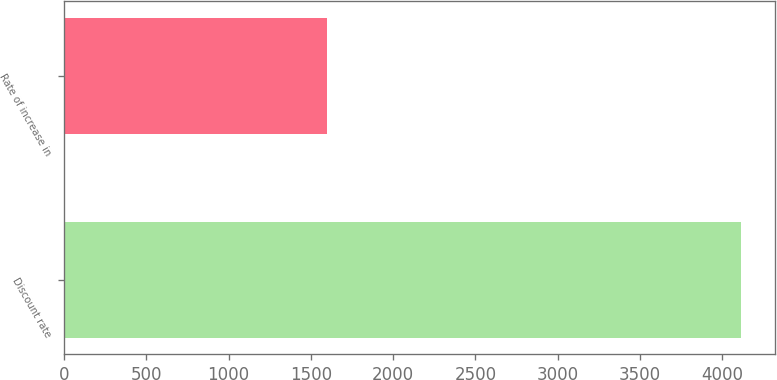Convert chart to OTSL. <chart><loc_0><loc_0><loc_500><loc_500><bar_chart><fcel>Discount rate<fcel>Rate of increase in<nl><fcel>4115<fcel>1600<nl></chart> 